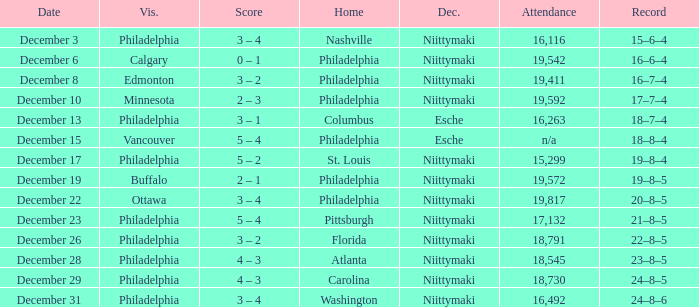What was the decision when the attendance was 19,592? Niittymaki. 